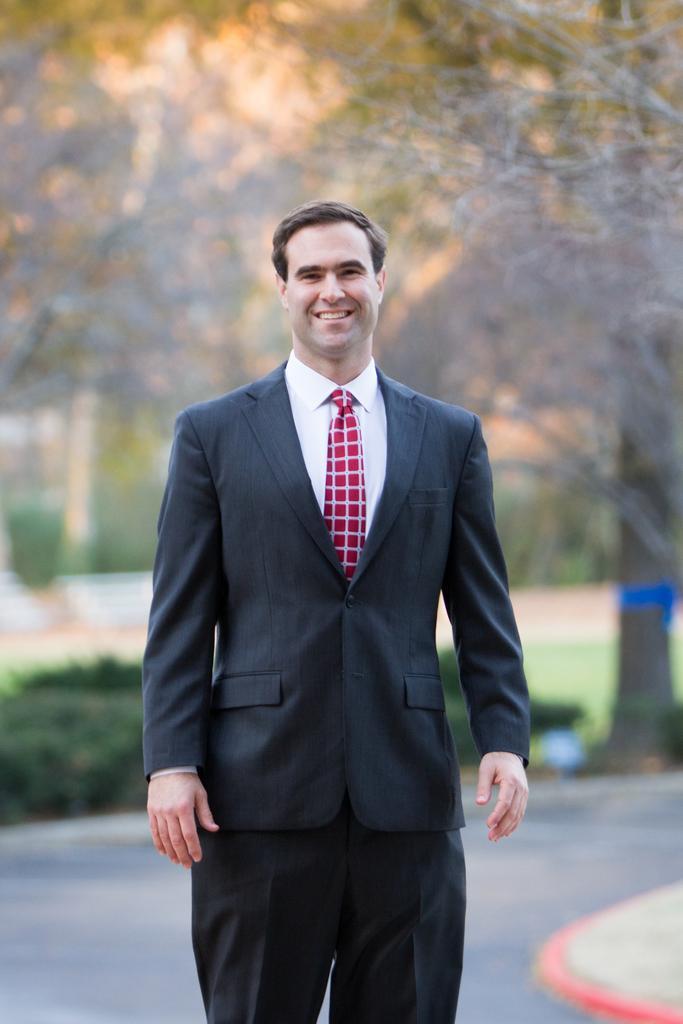Can you describe this image briefly? In this image, at the middle we can see a man standing and he is wearing a black color and a red color tie, he is smiling, in the background there is a road and there is a tree. 